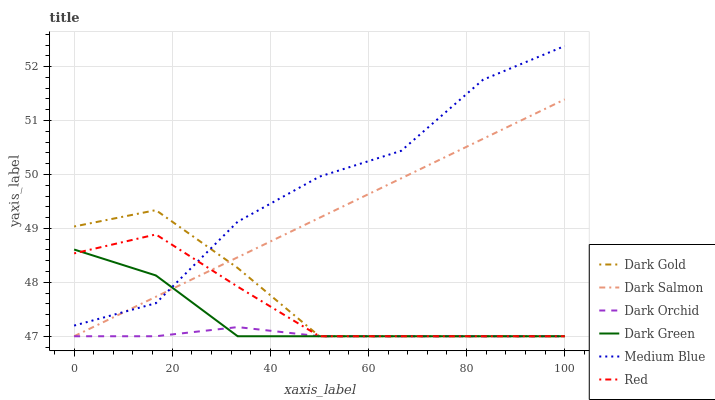Does Dark Orchid have the minimum area under the curve?
Answer yes or no. Yes. Does Medium Blue have the maximum area under the curve?
Answer yes or no. Yes. Does Dark Salmon have the minimum area under the curve?
Answer yes or no. No. Does Dark Salmon have the maximum area under the curve?
Answer yes or no. No. Is Dark Salmon the smoothest?
Answer yes or no. Yes. Is Medium Blue the roughest?
Answer yes or no. Yes. Is Medium Blue the smoothest?
Answer yes or no. No. Is Dark Salmon the roughest?
Answer yes or no. No. Does Medium Blue have the lowest value?
Answer yes or no. No. Does Medium Blue have the highest value?
Answer yes or no. Yes. Does Dark Salmon have the highest value?
Answer yes or no. No. Is Dark Orchid less than Medium Blue?
Answer yes or no. Yes. Is Medium Blue greater than Dark Orchid?
Answer yes or no. Yes. Does Red intersect Dark Salmon?
Answer yes or no. Yes. Is Red less than Dark Salmon?
Answer yes or no. No. Is Red greater than Dark Salmon?
Answer yes or no. No. Does Dark Orchid intersect Medium Blue?
Answer yes or no. No. 